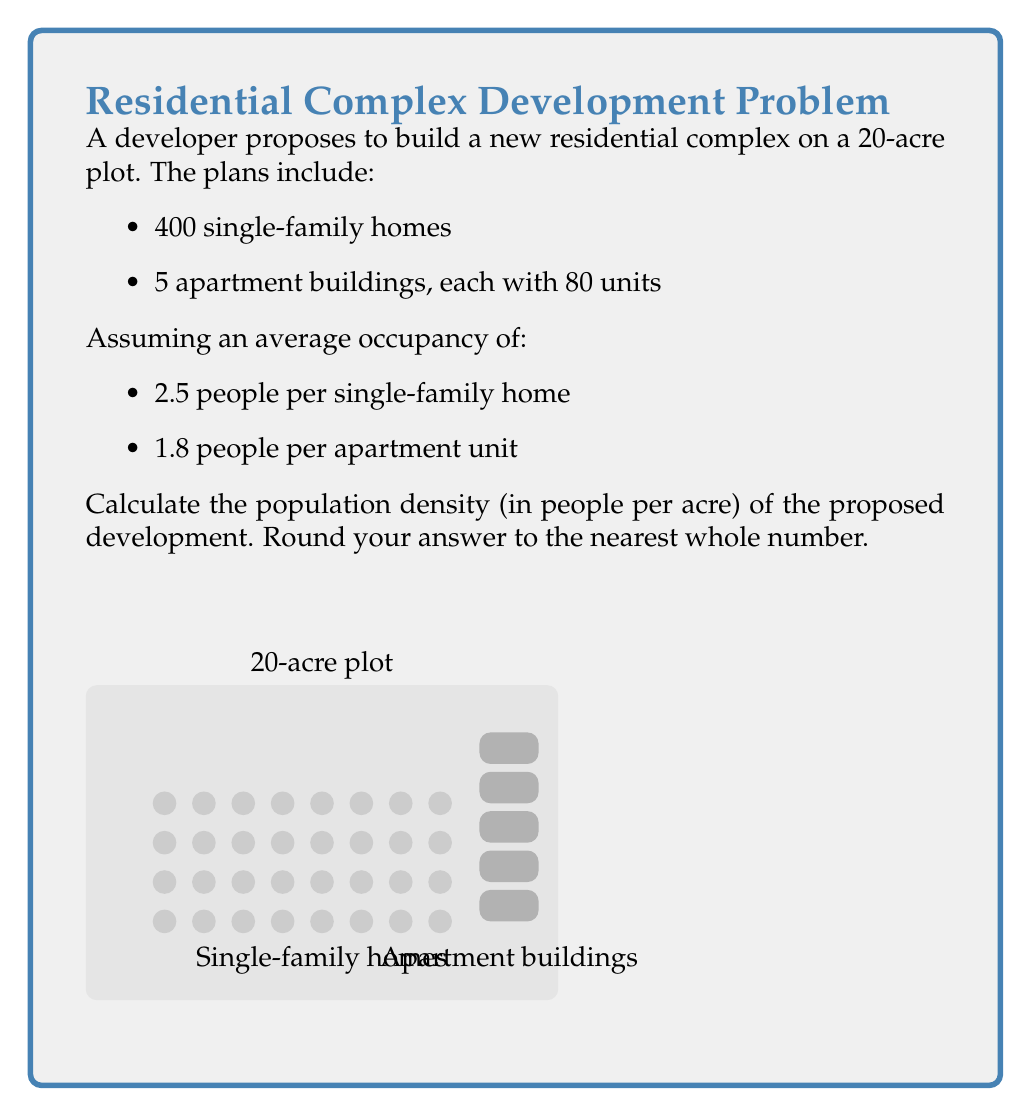Provide a solution to this math problem. Let's break this problem down step-by-step:

1) First, calculate the total number of residential units:
   Single-family homes: 400
   Apartment units: $5 \times 80 = 400$
   Total units: $400 + 400 = 800$

2) Now, calculate the total population:
   Single-family homes: $400 \times 2.5 = 1000$ people
   Apartment units: $400 \times 1.8 = 720$ people
   Total population: $1000 + 720 = 1720$ people

3) The population density is calculated by dividing the total population by the area:

   $\text{Population Density} = \frac{\text{Total Population}}{\text{Total Area}}$

   $\text{Population Density} = \frac{1720 \text{ people}}{20 \text{ acres}}$

4) Perform the division:
   $\frac{1720}{20} = 86$ people per acre

5) The question asks to round to the nearest whole number, but 86 is already a whole number, so no rounding is necessary.
Answer: 86 people per acre 